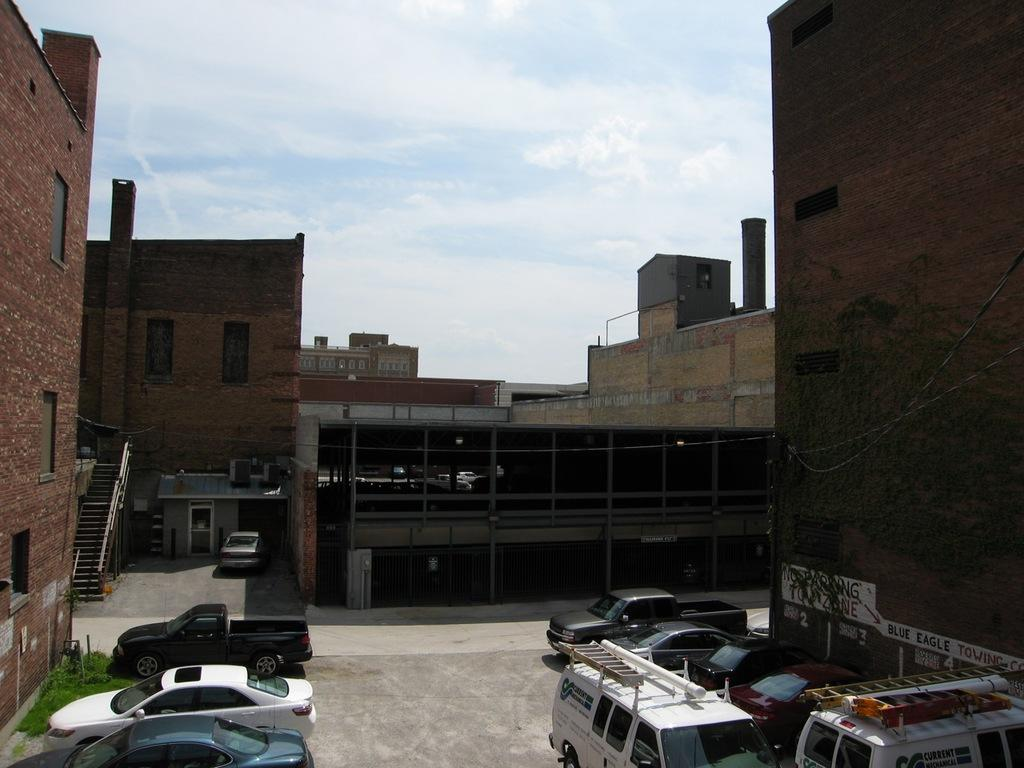What is happening on the road in the image? There are vehicles on the road in the image. What can be seen in the distance behind the vehicles? There are buildings, grass, and the sky visible in the background of the image. Can you describe the unspecified objects in the background? Unfortunately, the provided facts do not specify the nature of the unspecified objects in the background. How many hands are visible holding the steering wheel in the image? There is no information about hands or steering wheels in the provided facts, so we cannot answer this question. 